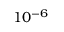<formula> <loc_0><loc_0><loc_500><loc_500>1 0 ^ { - 6 }</formula> 